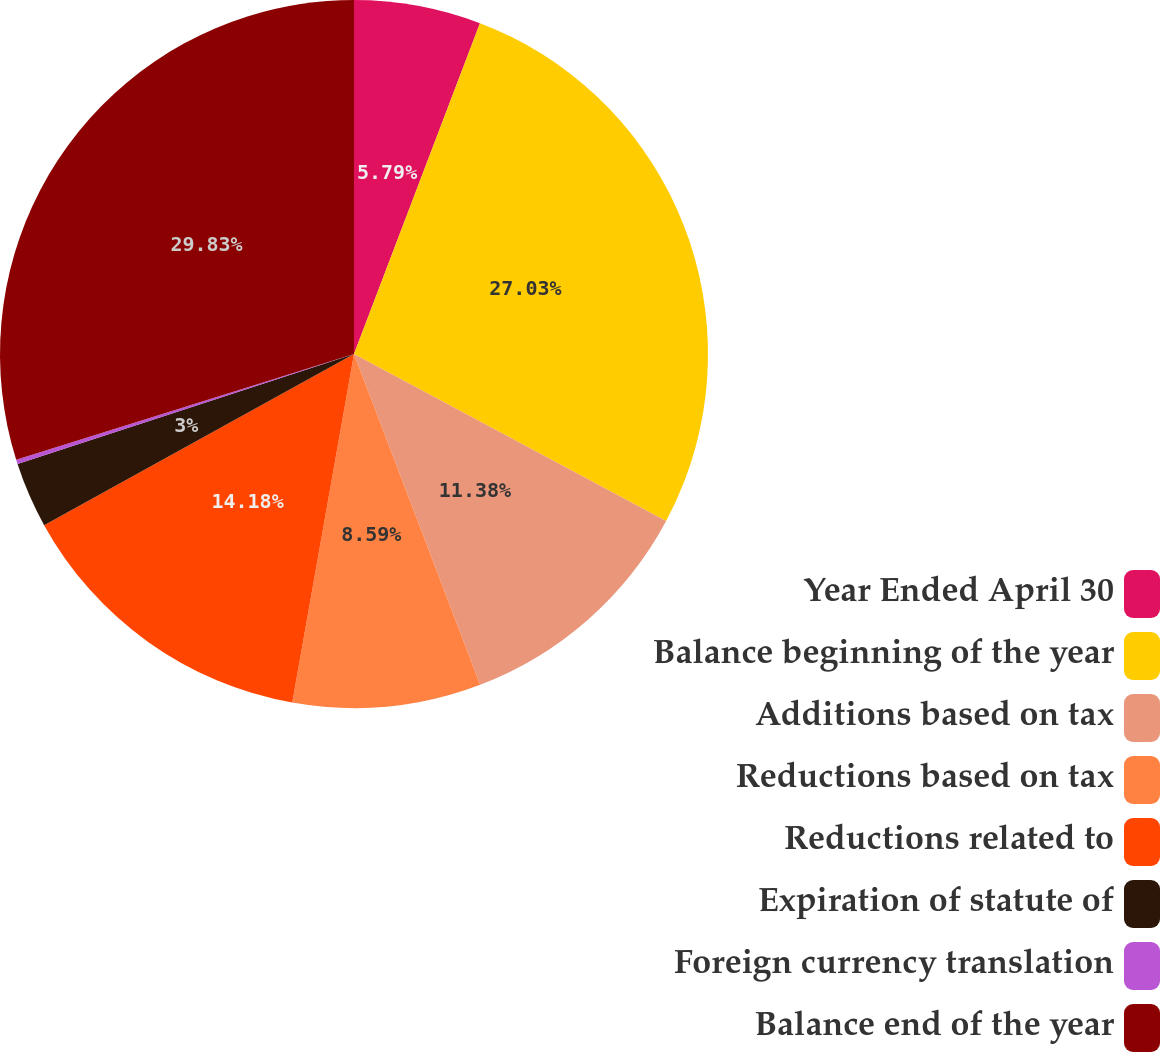Convert chart to OTSL. <chart><loc_0><loc_0><loc_500><loc_500><pie_chart><fcel>Year Ended April 30<fcel>Balance beginning of the year<fcel>Additions based on tax<fcel>Reductions based on tax<fcel>Reductions related to<fcel>Expiration of statute of<fcel>Foreign currency translation<fcel>Balance end of the year<nl><fcel>5.79%<fcel>27.03%<fcel>11.38%<fcel>8.59%<fcel>14.18%<fcel>3.0%<fcel>0.2%<fcel>29.83%<nl></chart> 